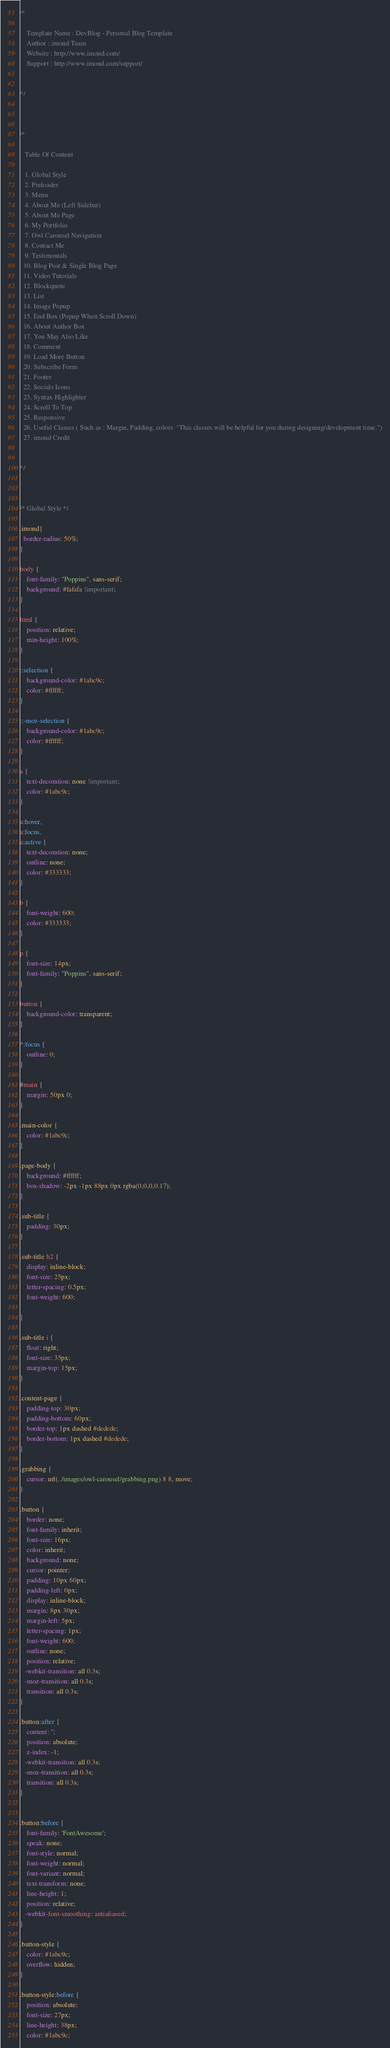Convert code to text. <code><loc_0><loc_0><loc_500><loc_500><_CSS_>/*

    Template Name : DevBlog - Personal Blog Template
    Author : imond Team
    Website : http://www.imond.com/
    Support : http://www.imond.com/support/


*/



/*

   Table Of Content

   1. Global Style
   2. Preloader
   3. Menu
   4. About Me (Left Sidebar)
   5. About Me Page
   6. My Portfolio
   7. Owl Carousel Navigation
   8. Contact Me
   9. Testimonials
  10. Blog Post & Single Blog Page
  11. Video Tutorials
  12. Blockquote
  13. List
  14. Image Popup
  15. End Box (Popup When Scroll Down)
  16. About Author Box
  17. You May Also Like
  18. Comment
  19. Load More Button
  20. Subscribe Form
  21. Footer
  22. Socials Icons
  23. Syntax Highlighter
  24. Scroll To Top
  25. Responsive
  26. Useful Classes ( Such as : Margin, Padding, colors  "This classes will be helpful for you during designing/development time.")
  27. imond Credit


*/



/* Global Style */

.imond{
  border-radius: 50%;
}

body {
    font-family: "Poppins", sans-serif;
    background: #fafafa !important;
}

html {
    position: relative;
    min-height: 100%;
}

::selection {
    background-color: #1abc9c;
    color: #ffffff;
}

::-moz-selection {
    background-color: #1abc9c;
    color: #ffffff;
}

a {
    text-decoration: none !important;
    color: #1abc9c;
}

a:hover,
a:focus,
a:active {
    text-decoration: none;
    outline: none;
    color: #333333;
}

b {
    font-weight: 600;
    color: #333333;
}

p {
    font-size: 14px;
    font-family: "Poppins", sans-serif;
}

button {
    background-color: transparent;
}

*:focus {
    outline: 0;
}

#main {
    margin: 50px 0;
}

.main-color {
    color: #1abc9c;
}

.page-body {
    background: #ffffff;
    box-shadow: -2px -1px 88px 0px rgba(0,0,0,0.17);
}

.sub-title {
    padding: 30px;
}

.sub-title h2 {
    display: inline-block;
    font-size: 25px;
    letter-spacing: 0.5px;
    font-weight: 600;

}

.sub-title i {
    float: right;
    font-size: 35px;
    margin-top: 15px;
}

.content-page {
    padding-top: 30px;
    padding-bottom: 60px;
    border-top: 1px dashed #dedede;
    border-bottom: 1px dashed #dedede;
}

.grabbing {
    cursor: url(../images/owl-carousel/grabbing.png) 8 8, move;
}

.button {
    border: none;
    font-family: inherit;
    font-size: 16px;
    color: inherit;
    background: none;
    cursor: pointer;
    padding: 10px 60px;
    padding-left: 0px;
    display: inline-block;
    margin: 8px 30px;
    margin-left: 5px;
    letter-spacing: 1px;
    font-weight: 600;
    outline: none;
    position: relative;
   -webkit-transition: all 0.3s;
   -moz-transition: all 0.3s;
    transition: all 0.3s;
}

.button:after {
    content: '';
    position: absolute;
    z-index: -1;
   -webkit-transition: all 0.3s;
   -moz-transition: all 0.3s;
    transition: all 0.3s;
}


.button:before {
    font-family: 'FontAwesome';
    speak: none;
    font-style: normal;
    font-weight: normal;
    font-variant: normal;
    text-transform: none;
    line-height: 1;
    position: relative;
   -webkit-font-smoothing: antialiased;
}

.button-style {
    color: #1abc9c;
    overflow: hidden;
}

.button-style:before {
    position: absolute;
    font-size: 27px;
    line-height: 38px;
    color: #1abc9c;</code> 